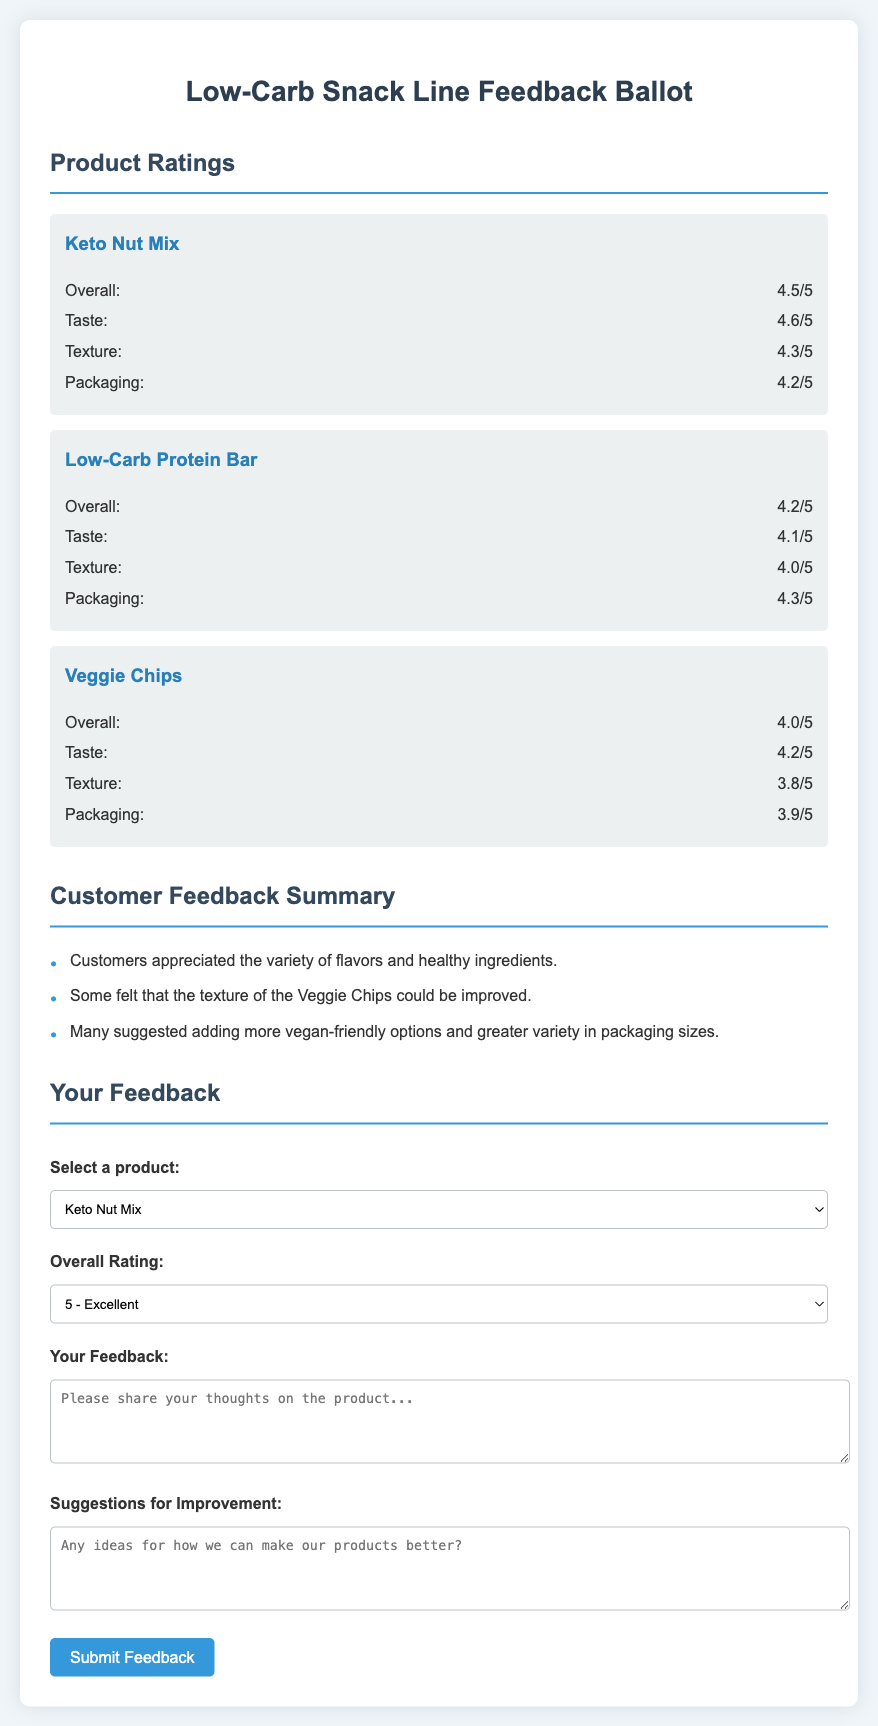What is the overall rating for Keto Nut Mix? The overall rating for Keto Nut Mix is stated in the document.
Answer: 4.5/5 What improvement suggestion was mentioned by customers? The document lists several customer feedback points and suggestions for improvement.
Answer: More vegan-friendly options What is the texture rating for Veggie Chips? The texture rating for Veggie Chips can be found in the product rating section of the document.
Answer: 3.8/5 What is the overall rating for Low-Carb Protein Bar? The overall rating for Low-Carb Protein Bar is provided in the document's product ratings.
Answer: 4.2/5 Which product received a taste rating of 4.6/5? The document specifies the ratings for different products, including taste ratings.
Answer: Keto Nut Mix What specific feedback was given regarding the Veggie Chips? The document outlines customer feedback regarding various aspects of the products, including Veggie Chips.
Answer: Texture could be improved How many products are listed in the feedback ballot? The document includes product ratings and contains specific information about the number of products featured.
Answer: Three What is the highest packaging rating among the three products? The packaging ratings for each product are shown, which can be compared to find the highest one.
Answer: 4.3/5 